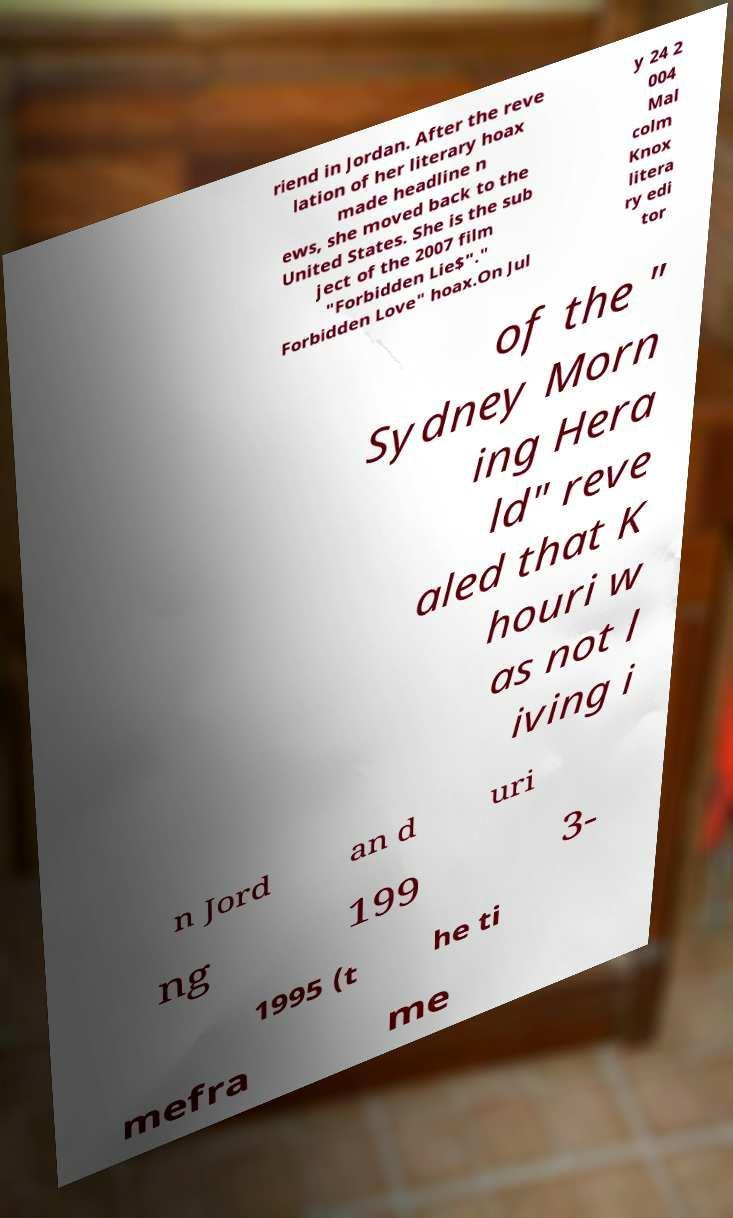Can you read and provide the text displayed in the image?This photo seems to have some interesting text. Can you extract and type it out for me? riend in Jordan. After the reve lation of her literary hoax made headline n ews, she moved back to the United States. She is the sub ject of the 2007 film "Forbidden Lie$"." Forbidden Love" hoax.On Jul y 24 2 004 Mal colm Knox litera ry edi tor of the " Sydney Morn ing Hera ld" reve aled that K houri w as not l iving i n Jord an d uri ng 199 3- 1995 (t he ti mefra me 